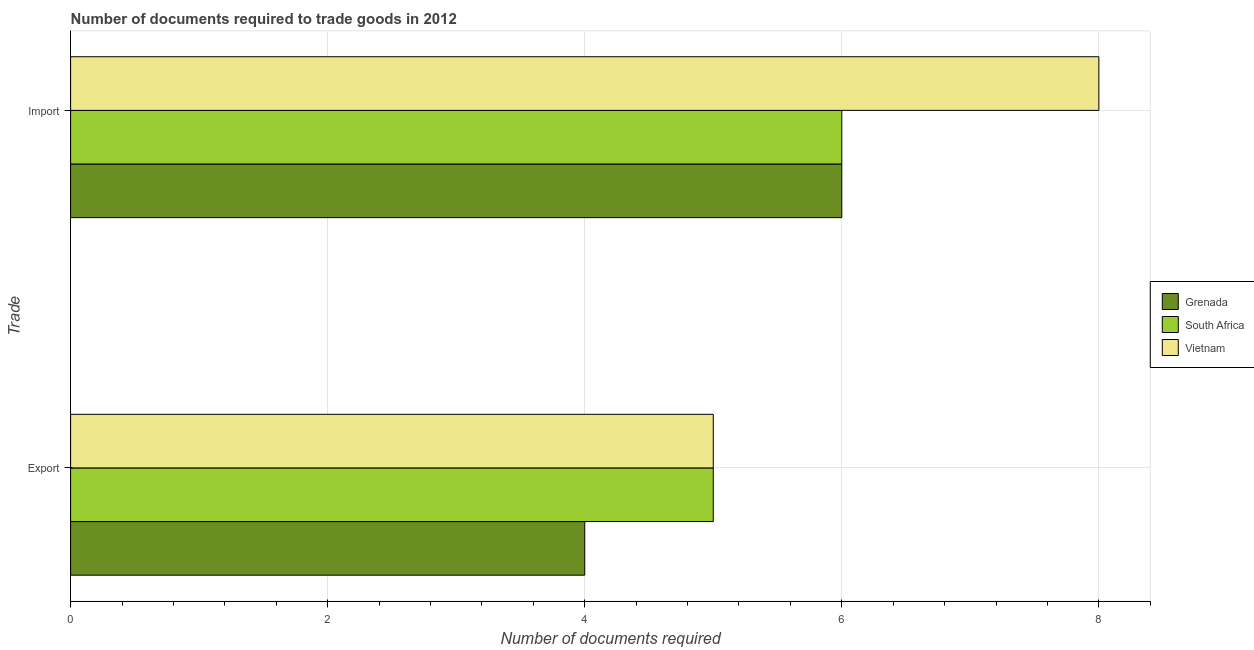How many different coloured bars are there?
Offer a very short reply. 3. How many groups of bars are there?
Provide a short and direct response. 2. Are the number of bars per tick equal to the number of legend labels?
Offer a terse response. Yes. What is the label of the 2nd group of bars from the top?
Make the answer very short. Export. What is the number of documents required to export goods in Grenada?
Offer a very short reply. 4. Across all countries, what is the maximum number of documents required to export goods?
Offer a terse response. 5. Across all countries, what is the minimum number of documents required to export goods?
Your answer should be very brief. 4. In which country was the number of documents required to import goods maximum?
Provide a succinct answer. Vietnam. In which country was the number of documents required to export goods minimum?
Your answer should be compact. Grenada. What is the total number of documents required to export goods in the graph?
Ensure brevity in your answer.  14. What is the difference between the number of documents required to export goods in Grenada and that in Vietnam?
Make the answer very short. -1. What is the difference between the number of documents required to import goods in South Africa and the number of documents required to export goods in Vietnam?
Offer a terse response. 1. What is the average number of documents required to import goods per country?
Offer a terse response. 6.67. What is the difference between the number of documents required to import goods and number of documents required to export goods in South Africa?
Your answer should be very brief. 1. In how many countries, is the number of documents required to export goods greater than 3.2 ?
Ensure brevity in your answer.  3. What is the ratio of the number of documents required to export goods in Vietnam to that in Grenada?
Provide a succinct answer. 1.25. In how many countries, is the number of documents required to export goods greater than the average number of documents required to export goods taken over all countries?
Ensure brevity in your answer.  2. What does the 2nd bar from the top in Import represents?
Keep it short and to the point. South Africa. What does the 2nd bar from the bottom in Export represents?
Your response must be concise. South Africa. Does the graph contain any zero values?
Provide a short and direct response. No. What is the title of the graph?
Your answer should be very brief. Number of documents required to trade goods in 2012. What is the label or title of the X-axis?
Ensure brevity in your answer.  Number of documents required. What is the label or title of the Y-axis?
Offer a terse response. Trade. What is the Number of documents required in Grenada in Export?
Your response must be concise. 4. What is the Number of documents required in Vietnam in Export?
Your answer should be compact. 5. What is the Number of documents required of Grenada in Import?
Provide a short and direct response. 6. What is the Number of documents required of South Africa in Import?
Provide a succinct answer. 6. What is the Number of documents required of Vietnam in Import?
Offer a terse response. 8. Across all Trade, what is the maximum Number of documents required of Grenada?
Your answer should be compact. 6. Across all Trade, what is the maximum Number of documents required of South Africa?
Keep it short and to the point. 6. Across all Trade, what is the minimum Number of documents required in Grenada?
Offer a very short reply. 4. Across all Trade, what is the minimum Number of documents required of Vietnam?
Make the answer very short. 5. What is the total Number of documents required of South Africa in the graph?
Provide a short and direct response. 11. What is the total Number of documents required in Vietnam in the graph?
Keep it short and to the point. 13. What is the difference between the Number of documents required in Grenada in Export and that in Import?
Your response must be concise. -2. What is the difference between the Number of documents required of Grenada in Export and the Number of documents required of South Africa in Import?
Keep it short and to the point. -2. What is the average Number of documents required in Grenada per Trade?
Keep it short and to the point. 5. What is the average Number of documents required of South Africa per Trade?
Offer a very short reply. 5.5. What is the difference between the Number of documents required in Grenada and Number of documents required in South Africa in Export?
Provide a short and direct response. -1. What is the difference between the Number of documents required of Grenada and Number of documents required of Vietnam in Export?
Ensure brevity in your answer.  -1. What is the ratio of the Number of documents required of South Africa in Export to that in Import?
Provide a succinct answer. 0.83. What is the difference between the highest and the second highest Number of documents required in Grenada?
Offer a terse response. 2. What is the difference between the highest and the second highest Number of documents required in Vietnam?
Make the answer very short. 3. 